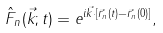<formula> <loc_0><loc_0><loc_500><loc_500>\hat { F } _ { n } ( \vec { k } ; t ) = e ^ { i \vec { k } \cdot [ \vec { r } _ { n } ( t ) - \vec { r } _ { n } ( 0 ) ] } ,</formula> 